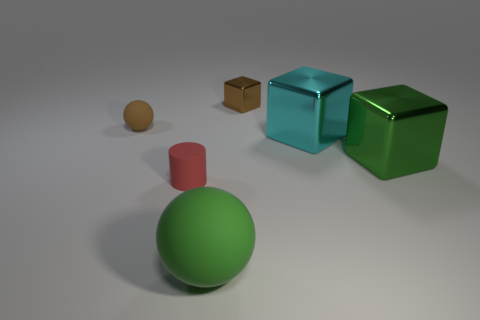Is the tiny shiny thing the same color as the small matte ball?
Give a very brief answer. Yes. There is a shiny thing that is the same color as the small rubber ball; what is its size?
Offer a terse response. Small. There is a ball that is behind the green object right of the ball that is in front of the big cyan object; what color is it?
Your answer should be very brief. Brown. There is a thing that is both to the right of the red matte object and on the left side of the brown cube; what is its shape?
Keep it short and to the point. Sphere. How many other things are there of the same shape as the green matte object?
Give a very brief answer. 1. There is a brown thing that is on the right side of the matte ball behind the big thing that is in front of the red matte cylinder; what shape is it?
Your answer should be compact. Cube. There is a green object in front of the tiny red rubber cylinder; is its shape the same as the tiny brown object that is in front of the brown metal cube?
Keep it short and to the point. Yes. Are the small brown object that is in front of the brown block and the red object made of the same material?
Provide a succinct answer. Yes. Is there another tiny shiny object that has the same shape as the green metal object?
Make the answer very short. Yes. What material is the green object that is on the right side of the sphere that is in front of the big cyan shiny object made of?
Give a very brief answer. Metal. 